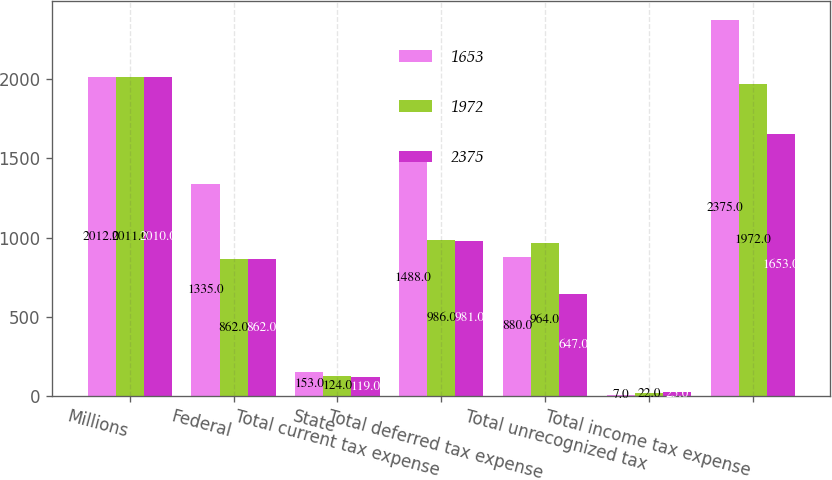Convert chart. <chart><loc_0><loc_0><loc_500><loc_500><stacked_bar_chart><ecel><fcel>Millions<fcel>Federal<fcel>State<fcel>Total current tax expense<fcel>Total deferred tax expense<fcel>Total unrecognized tax<fcel>Total income tax expense<nl><fcel>1653<fcel>2012<fcel>1335<fcel>153<fcel>1488<fcel>880<fcel>7<fcel>2375<nl><fcel>1972<fcel>2011<fcel>862<fcel>124<fcel>986<fcel>964<fcel>22<fcel>1972<nl><fcel>2375<fcel>2010<fcel>862<fcel>119<fcel>981<fcel>647<fcel>25<fcel>1653<nl></chart> 